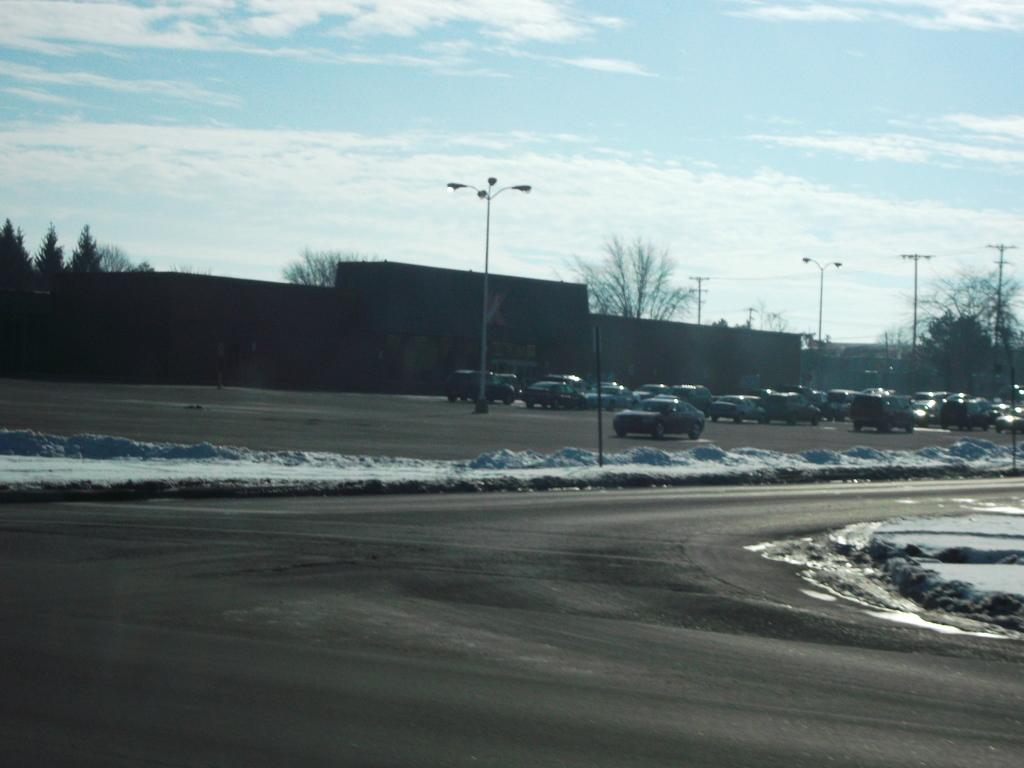What is the main feature of the image? There is a road in the image. What is happening on the road? There are cars on the road. What else can be seen in the image besides the road and cars? There are poles, trees, a wall, and the sky visible in the image. What is the condition of the sky in the image? The sky is visible in the background of the image, and there are clouds in the sky. What type of hate can be seen being offered to the part of the wall in the image? There is no hate or offer present in the image; it features a road with cars, poles, trees, a wall, and a sky with clouds. 